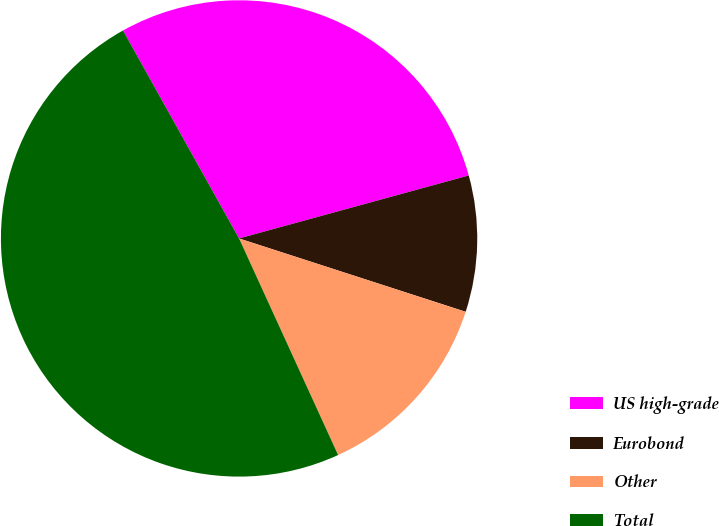Convert chart to OTSL. <chart><loc_0><loc_0><loc_500><loc_500><pie_chart><fcel>US high-grade<fcel>Eurobond<fcel>Other<fcel>Total<nl><fcel>28.84%<fcel>9.24%<fcel>13.19%<fcel>48.72%<nl></chart> 